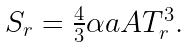<formula> <loc_0><loc_0><loc_500><loc_500>\begin{array} { c } S _ { r } = \frac { 4 } { 3 } \alpha a A T _ { r } ^ { 3 } . \end{array}</formula> 